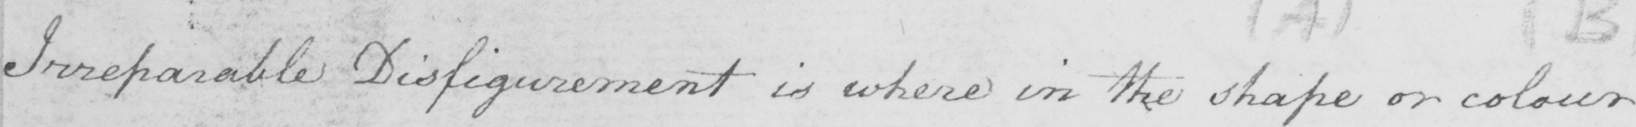Please provide the text content of this handwritten line. Irreparable Disfigurement is where in the shape or colour 